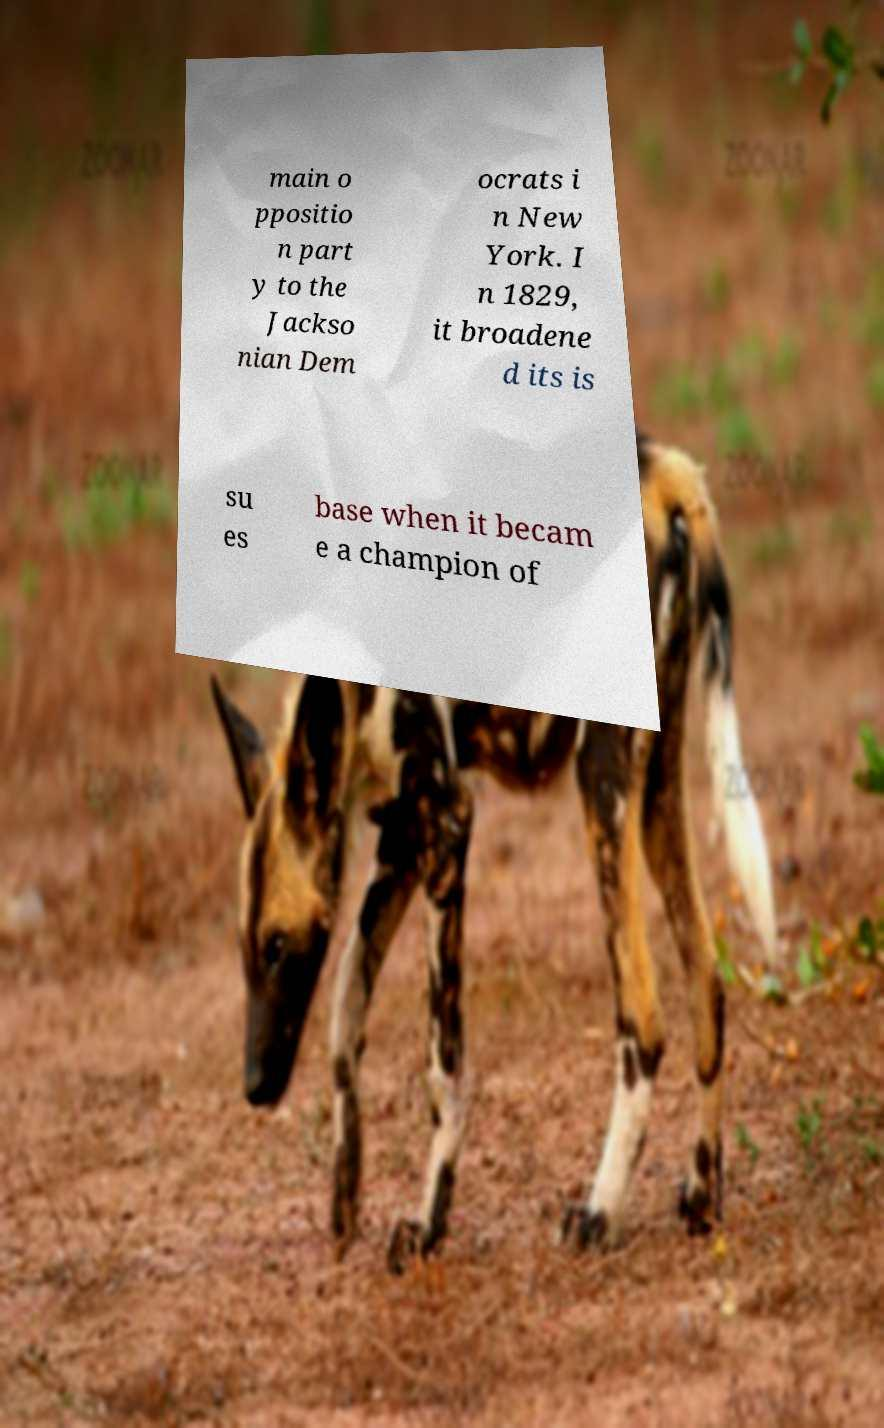Can you accurately transcribe the text from the provided image for me? main o ppositio n part y to the Jackso nian Dem ocrats i n New York. I n 1829, it broadene d its is su es base when it becam e a champion of 